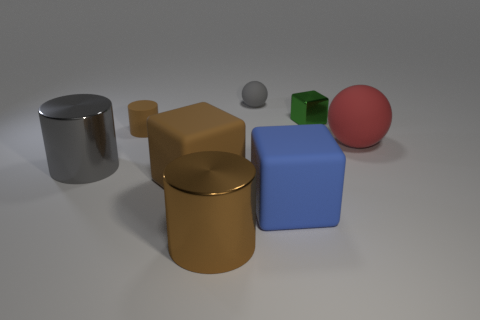Is the number of shiny things that are left of the tiny metal block greater than the number of big matte blocks behind the big red matte object?
Keep it short and to the point. Yes. Do the ball behind the small cylinder and the metallic cylinder left of the rubber cylinder have the same color?
Give a very brief answer. Yes. What shape is the gray thing that is the same size as the blue thing?
Ensure brevity in your answer.  Cylinder. Is there a big blue rubber object that has the same shape as the tiny gray thing?
Keep it short and to the point. No. Is the brown object behind the red thing made of the same material as the big cylinder behind the big brown matte cube?
Your response must be concise. No. What is the shape of the big metallic object that is the same color as the tiny ball?
Offer a very short reply. Cylinder. How many other brown objects are made of the same material as the tiny brown object?
Make the answer very short. 1. What color is the tiny shiny object?
Keep it short and to the point. Green. There is a gray object right of the big gray thing; does it have the same shape as the big rubber object behind the gray metallic object?
Your answer should be compact. Yes. The ball that is left of the big blue rubber cube is what color?
Make the answer very short. Gray. 